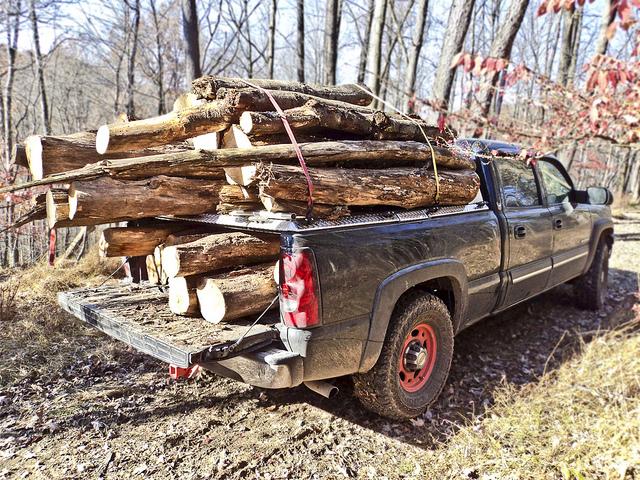What kind of road is the truck on?
Concise answer only. Dirt. Who is driving the truck?
Concise answer only. Man. What is in the back of this truck?
Short answer required. Logs. 